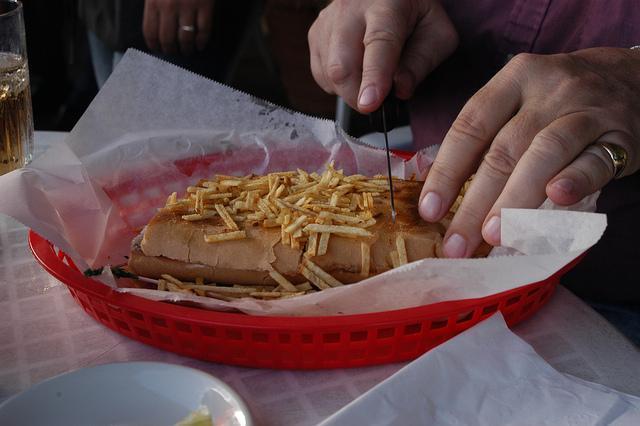How many sandwiches do you see?
Give a very brief answer. 1. 